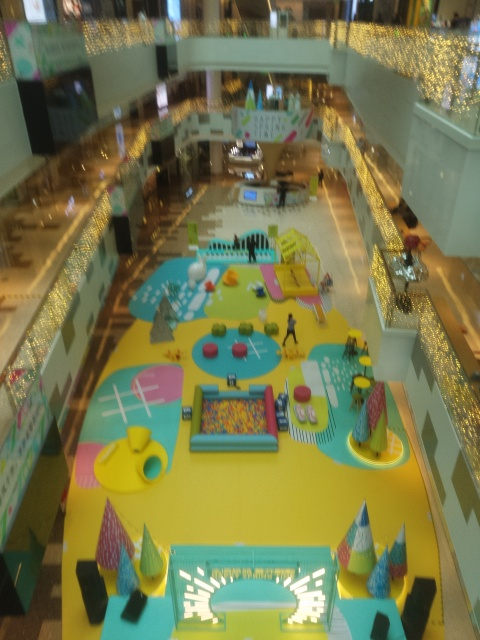Does the image show any signs of ongoing activities or events? While there are no clear indications of an event currently in progress, the installations hint at interactive use, perhaps during specific hours or events. The presence of figures that appear to be people suggests the space is accessible and possibly in use, but the absence of crowds might mean there is no large-scale event happening at the moment the picture was taken. What time of day does it seem to be in the image? Given the ample lighting, both natural and artificial, and the visibility throughout the space, it could be during retail hours. However, the exact time of day is difficult to determine without clear indicators such as windows showing outdoor light or shadows that might give clues to the position of the sun. 